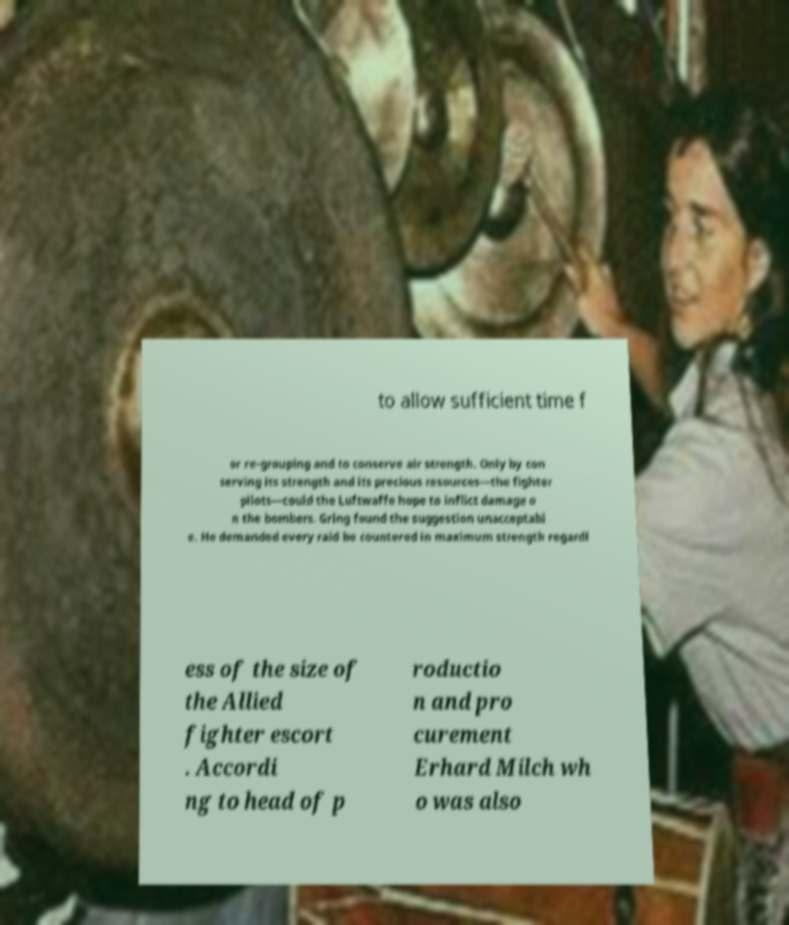Could you assist in decoding the text presented in this image and type it out clearly? to allow sufficient time f or re-grouping and to conserve air strength. Only by con serving its strength and its precious resources—the fighter pilots—could the Luftwaffe hope to inflict damage o n the bombers. Gring found the suggestion unacceptabl e. He demanded every raid be countered in maximum strength regardl ess of the size of the Allied fighter escort . Accordi ng to head of p roductio n and pro curement Erhard Milch wh o was also 